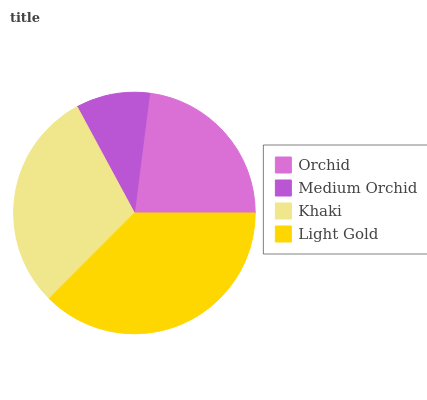Is Medium Orchid the minimum?
Answer yes or no. Yes. Is Light Gold the maximum?
Answer yes or no. Yes. Is Khaki the minimum?
Answer yes or no. No. Is Khaki the maximum?
Answer yes or no. No. Is Khaki greater than Medium Orchid?
Answer yes or no. Yes. Is Medium Orchid less than Khaki?
Answer yes or no. Yes. Is Medium Orchid greater than Khaki?
Answer yes or no. No. Is Khaki less than Medium Orchid?
Answer yes or no. No. Is Khaki the high median?
Answer yes or no. Yes. Is Orchid the low median?
Answer yes or no. Yes. Is Light Gold the high median?
Answer yes or no. No. Is Light Gold the low median?
Answer yes or no. No. 